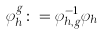<formula> <loc_0><loc_0><loc_500><loc_500>\varphi _ { h } ^ { g } \colon = \varphi _ { h , g } ^ { - 1 } \varphi _ { h }</formula> 